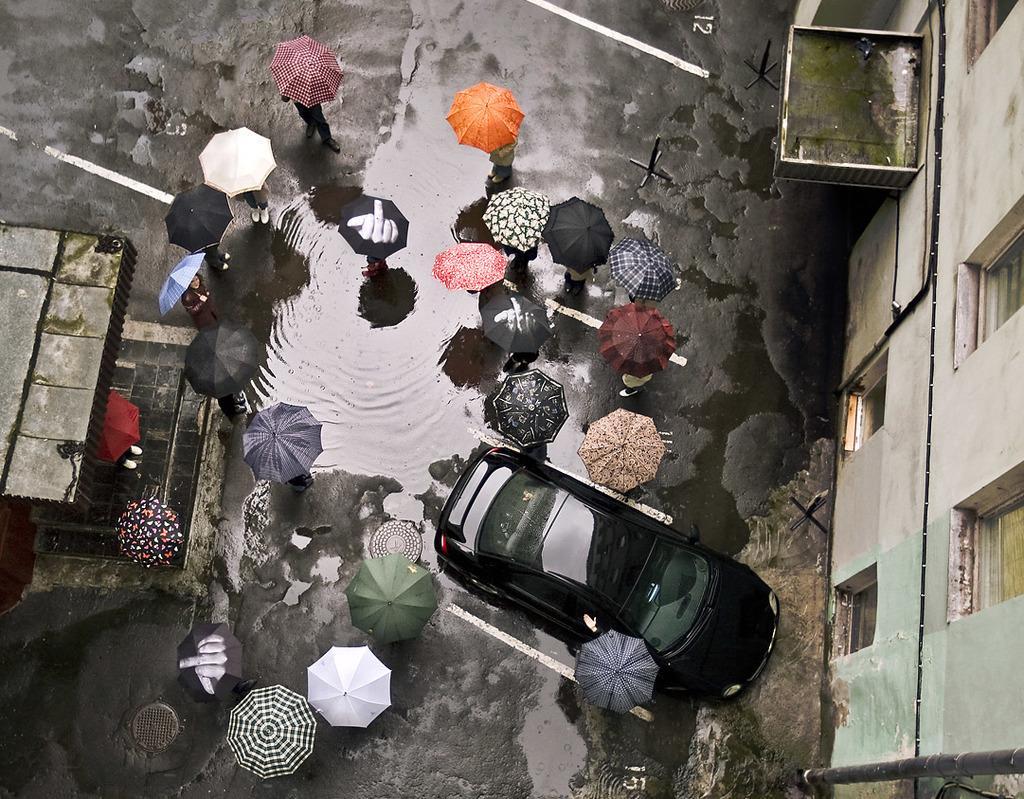Describe this image in one or two sentences. This image is clicked from a top view. There is a road in the image. There are people standing and holding umbrellas in their hands. In the center there is water on the road. To the right there is a building. To the left there is a shed. There is a car in front of the building. 